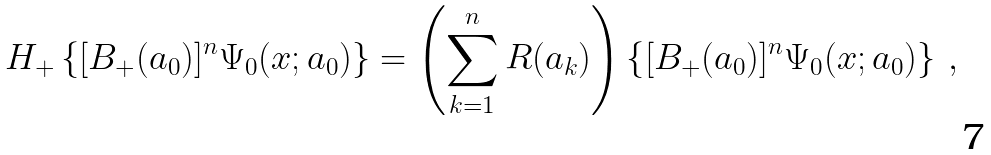Convert formula to latex. <formula><loc_0><loc_0><loc_500><loc_500>H _ { + } \left \{ [ B _ { + } ( a _ { 0 } ) ] ^ { n } \Psi _ { 0 } ( x ; a _ { 0 } ) \right \} = \left ( \sum _ { k = 1 } ^ { n } R ( a _ { k } ) \right ) \left \{ [ B _ { + } ( a _ { 0 } ) ] ^ { n } \Psi _ { 0 } ( x ; a _ { 0 } ) \right \} \, ,</formula> 